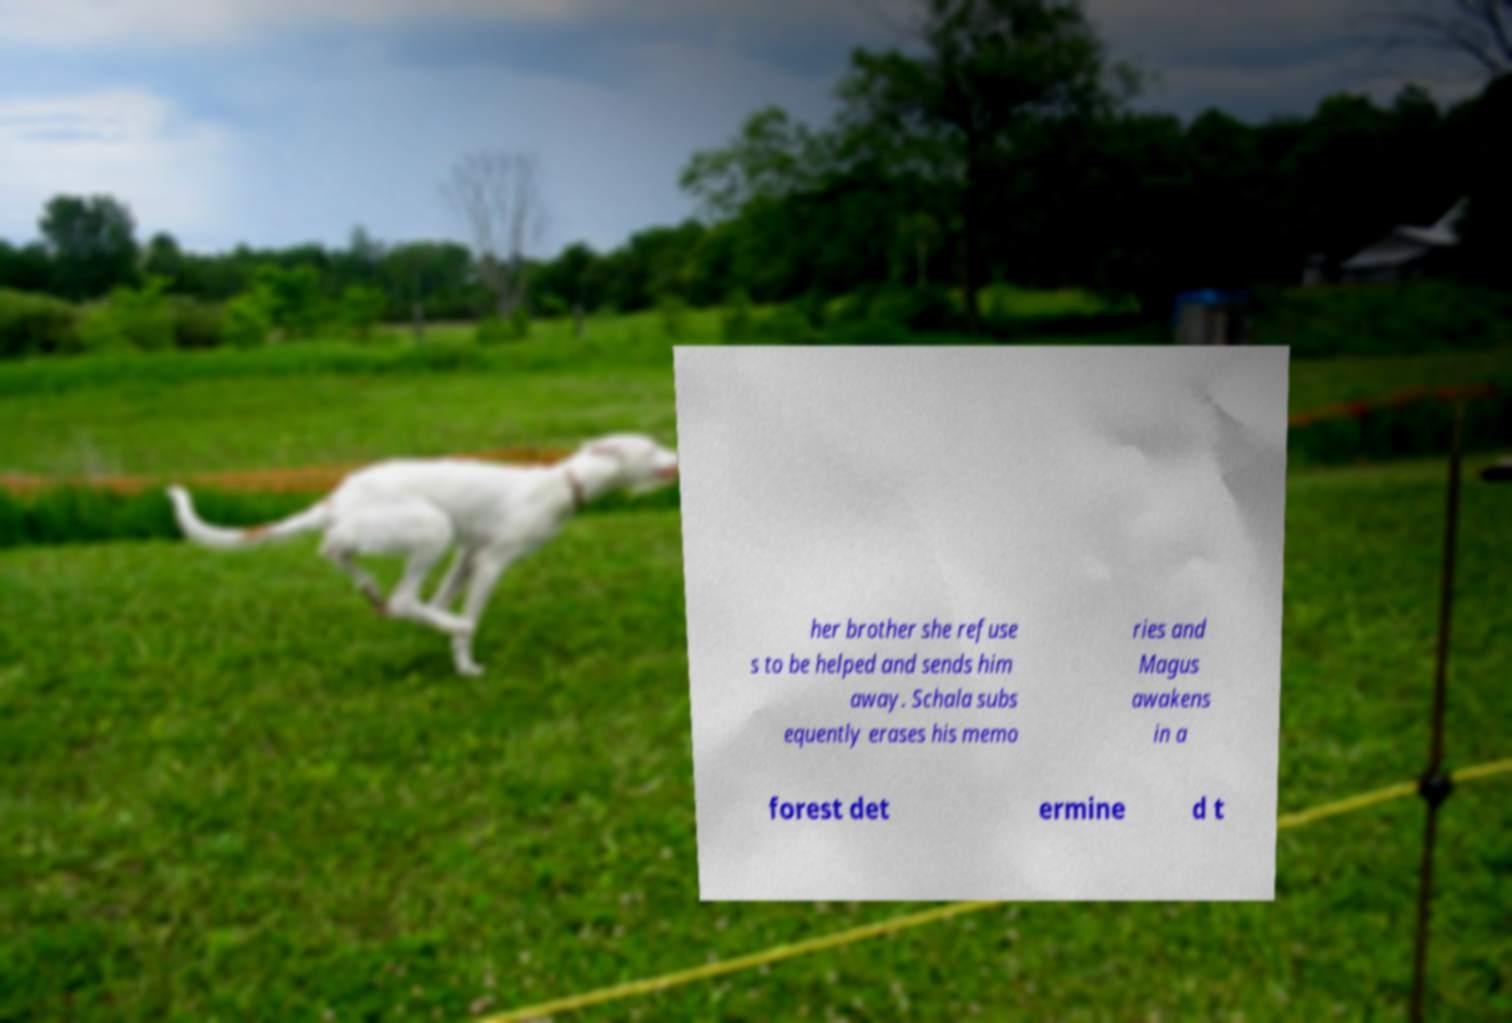Could you extract and type out the text from this image? her brother she refuse s to be helped and sends him away. Schala subs equently erases his memo ries and Magus awakens in a forest det ermine d t 